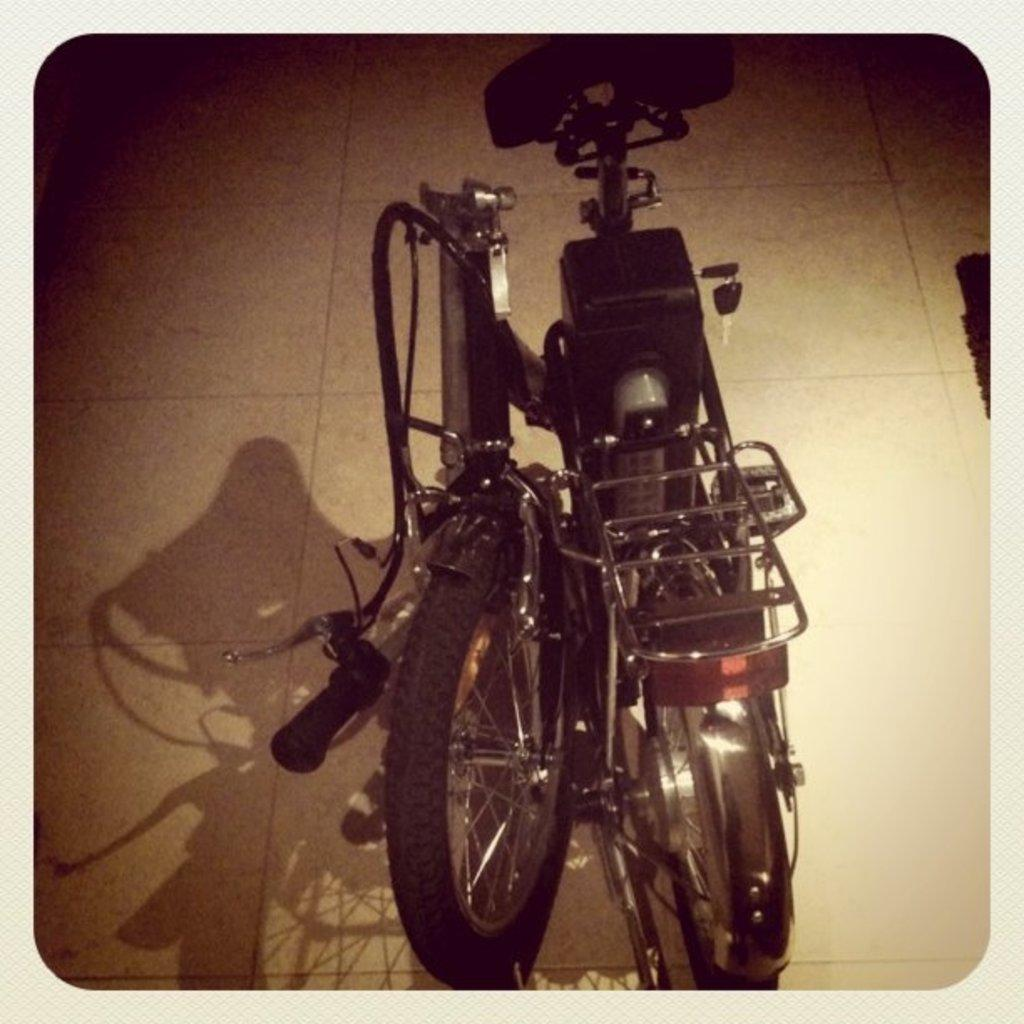What is placed on the floor in the image? There is a bicycle on the floor in the image. Can you describe the object that is truncated towards the right side of the image? Unfortunately, the object is not fully visible in the image, so it cannot be described accurately. How many sticks of butter are placed on the bicycle in the image? There are no sticks of butter present in the image; it features a bicycle on the floor. What type of cow can be seen grazing near the bicycle in the image? There is no cow present in the image; it only features a bicycle on the floor. 